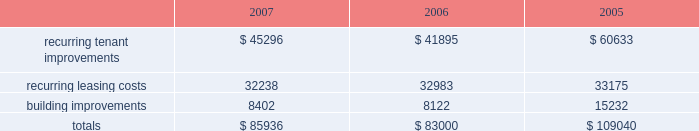In february 2008 , we issued $ 300.0 million of 8.375% ( 8.375 % ) series o cumulative redeemable preferred shares .
The indentures ( and related supplemental indentures ) governing our outstanding series of notes also require us to comply with financial ratios and other covenants regarding our operations .
We were in compliance with all such covenants as of december 31 , 2007 .
Sale of real estate assets we utilize sales of real estate assets as an additional source of liquidity .
We pursue opportunities to sell real estate assets at favorable prices to capture value created by us as well as to improve the overall quality of our portfolio by recycling sale proceeds into new properties with greater value creation opportunities .
Uses of liquidity our principal uses of liquidity include the following : 2022 property investments ; 2022 recurring leasing/capital costs ; 2022 dividends and distributions to shareholders and unitholders ; 2022 long-term debt maturities ; and 2022 other contractual obligations property investments we evaluate development and acquisition opportunities based upon market outlook , supply and long-term growth potential .
Recurring expenditures one of our principal uses of our liquidity is to fund the recurring leasing/capital expenditures of our real estate investments .
The following is a summary of our recurring capital expenditures for the years ended december 31 , 2007 , 2006 and 2005 , respectively ( in thousands ) : .
Dividends and distributions in order to qualify as a reit for federal income tax purposes , we must currently distribute at least 90% ( 90 % ) of our taxable income to shareholders .
We paid dividends per share of $ 1.91 , $ 1.89 and $ 1.87 for the years ended december 31 , 2007 , 2006 and 2005 , respectively .
We also paid a one-time special dividend of $ 1.05 per share in 2005 as a result of the significant gain realized from an industrial portfolio sale .
We expect to continue to distribute taxable earnings to meet the requirements to maintain our reit status .
However , distributions are declared at the discretion of our board of directors and are subject to actual cash available for distribution , our financial condition , capital requirements and such other factors as our board of directors deems relevant .
Debt maturities debt outstanding at december 31 , 2007 totaled $ 4.3 billion with a weighted average interest rate of 5.74% ( 5.74 % ) maturing at various dates through 2028 .
We had $ 3.2 billion of unsecured notes , $ 546.1 million outstanding on our unsecured lines of credit and $ 524.4 million of secured debt outstanding at december 31 , 2007 .
Scheduled principal amortization and maturities of such debt totaled $ 249.8 million for the year ended december 31 , 2007 and $ 146.4 million of secured debt was transferred to unconsolidated subsidiaries in connection with the contribution of properties in 2007. .
In 2007 what was the percent of the total recurring capital expenditures that was associated with recurring leasing costs? 
Computations: (32238 / 85936)
Answer: 0.37514. 